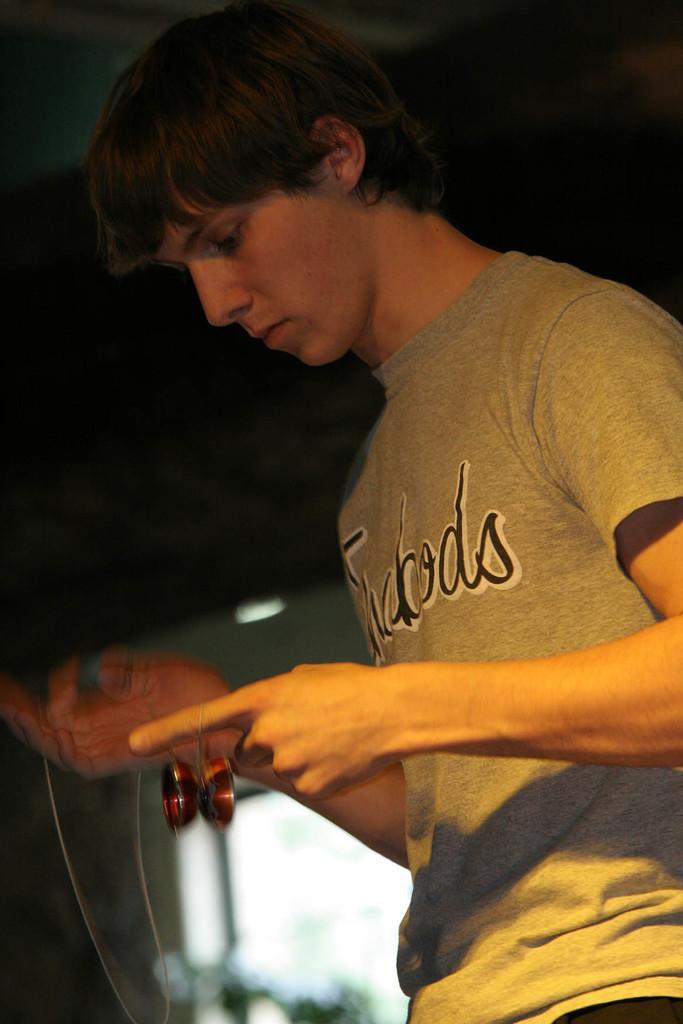In one or two sentences, can you explain what this image depicts? On the right side, there is a person in a T-shirt, holding an object. And the background is blurred. 